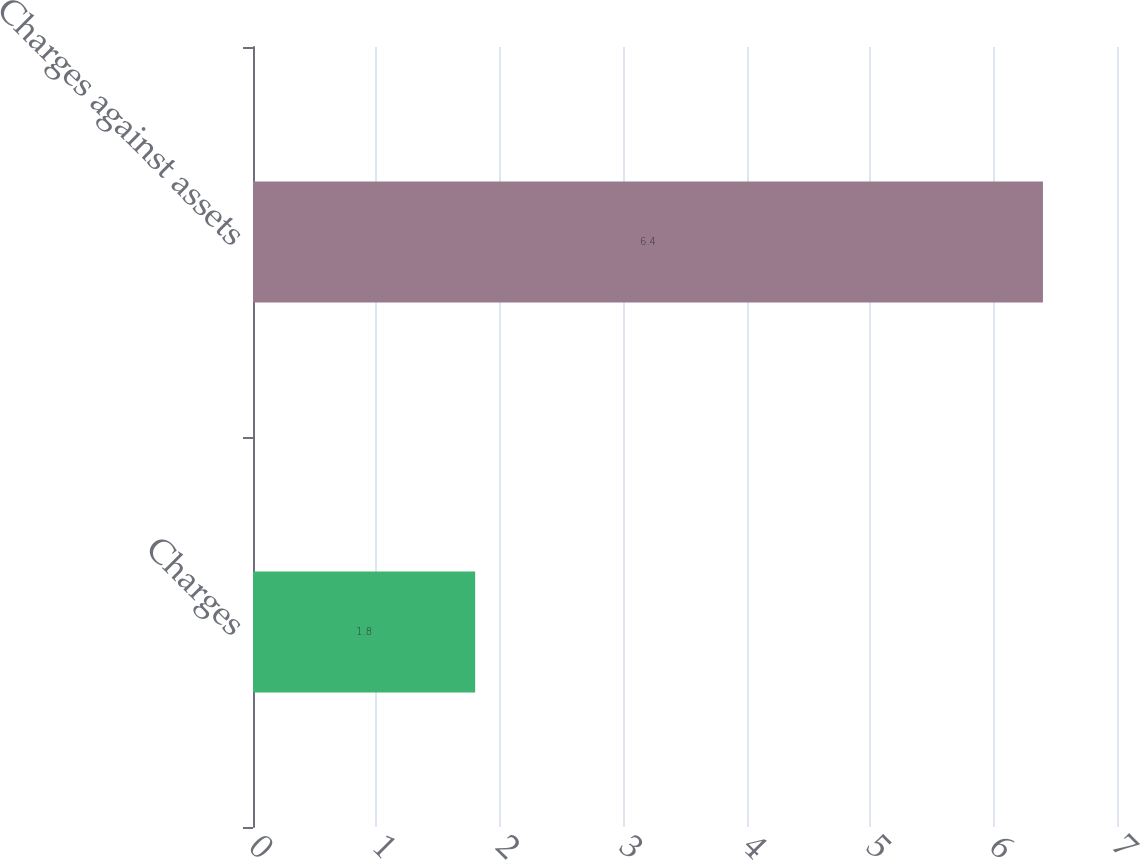<chart> <loc_0><loc_0><loc_500><loc_500><bar_chart><fcel>Charges<fcel>Charges against assets<nl><fcel>1.8<fcel>6.4<nl></chart> 